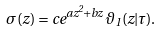<formula> <loc_0><loc_0><loc_500><loc_500>\sigma ( z ) = c e ^ { a z ^ { 2 } + b z } \vartheta _ { 1 } ( z | \tau ) .</formula> 